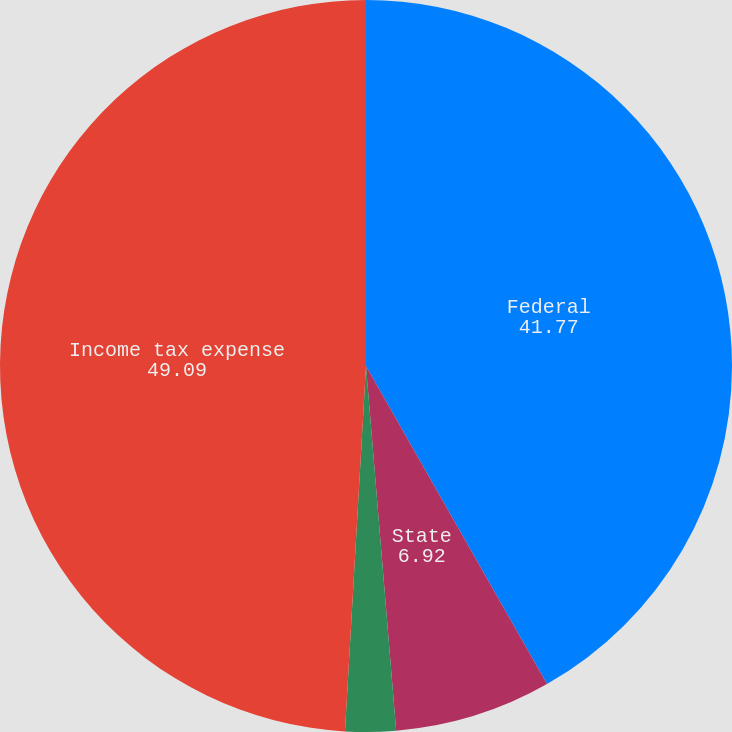Convert chart. <chart><loc_0><loc_0><loc_500><loc_500><pie_chart><fcel>Federal<fcel>State<fcel>Foreign<fcel>Income tax expense<nl><fcel>41.77%<fcel>6.92%<fcel>2.23%<fcel>49.09%<nl></chart> 